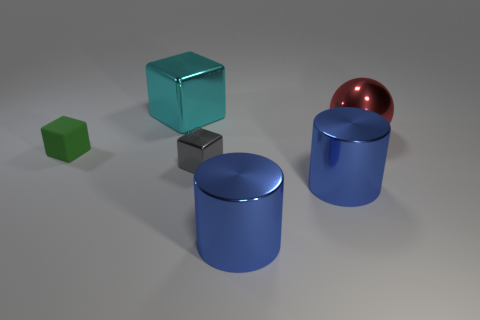Subtract all small green matte cubes. How many cubes are left? 2 Subtract all green blocks. How many blocks are left? 2 Add 4 big things. How many objects exist? 10 Subtract 1 cubes. How many cubes are left? 2 Subtract all purple cylinders. Subtract all brown blocks. How many cylinders are left? 2 Subtract all red cubes. How many cyan cylinders are left? 0 Subtract all big shiny blocks. Subtract all green objects. How many objects are left? 4 Add 1 red objects. How many red objects are left? 2 Add 2 metallic cylinders. How many metallic cylinders exist? 4 Subtract 0 purple balls. How many objects are left? 6 